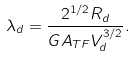Convert formula to latex. <formula><loc_0><loc_0><loc_500><loc_500>\lambda _ { d } = \frac { 2 ^ { 1 / 2 } R _ { d } } { G A _ { T F } V _ { d } ^ { 3 / 2 } } .</formula> 